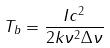Convert formula to latex. <formula><loc_0><loc_0><loc_500><loc_500>T _ { b } = \frac { I c ^ { 2 } } { 2 k \nu ^ { 2 } \Delta \nu }</formula> 